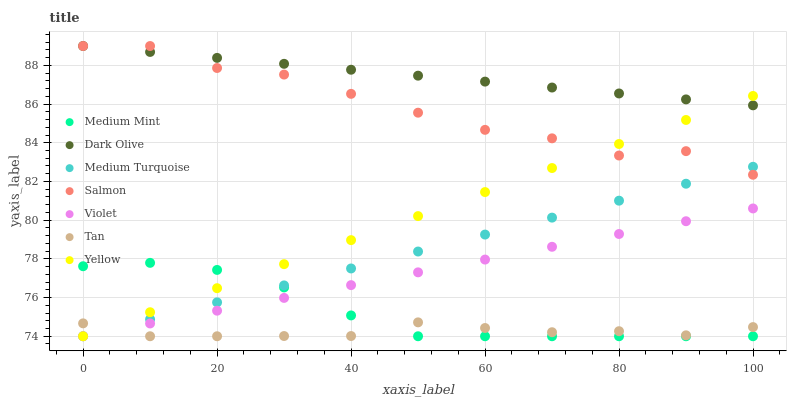Does Tan have the minimum area under the curve?
Answer yes or no. Yes. Does Dark Olive have the maximum area under the curve?
Answer yes or no. Yes. Does Salmon have the minimum area under the curve?
Answer yes or no. No. Does Salmon have the maximum area under the curve?
Answer yes or no. No. Is Yellow the smoothest?
Answer yes or no. Yes. Is Salmon the roughest?
Answer yes or no. Yes. Is Dark Olive the smoothest?
Answer yes or no. No. Is Dark Olive the roughest?
Answer yes or no. No. Does Medium Mint have the lowest value?
Answer yes or no. Yes. Does Salmon have the lowest value?
Answer yes or no. No. Does Salmon have the highest value?
Answer yes or no. Yes. Does Yellow have the highest value?
Answer yes or no. No. Is Tan less than Dark Olive?
Answer yes or no. Yes. Is Dark Olive greater than Violet?
Answer yes or no. Yes. Does Tan intersect Violet?
Answer yes or no. Yes. Is Tan less than Violet?
Answer yes or no. No. Is Tan greater than Violet?
Answer yes or no. No. Does Tan intersect Dark Olive?
Answer yes or no. No. 